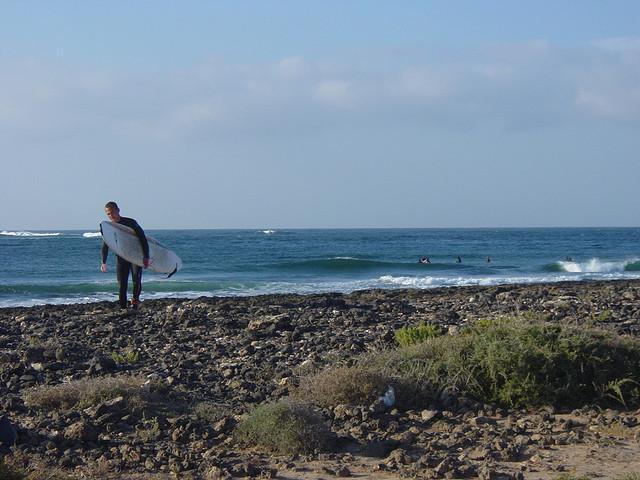How many people are there?
Give a very brief answer. 1. 